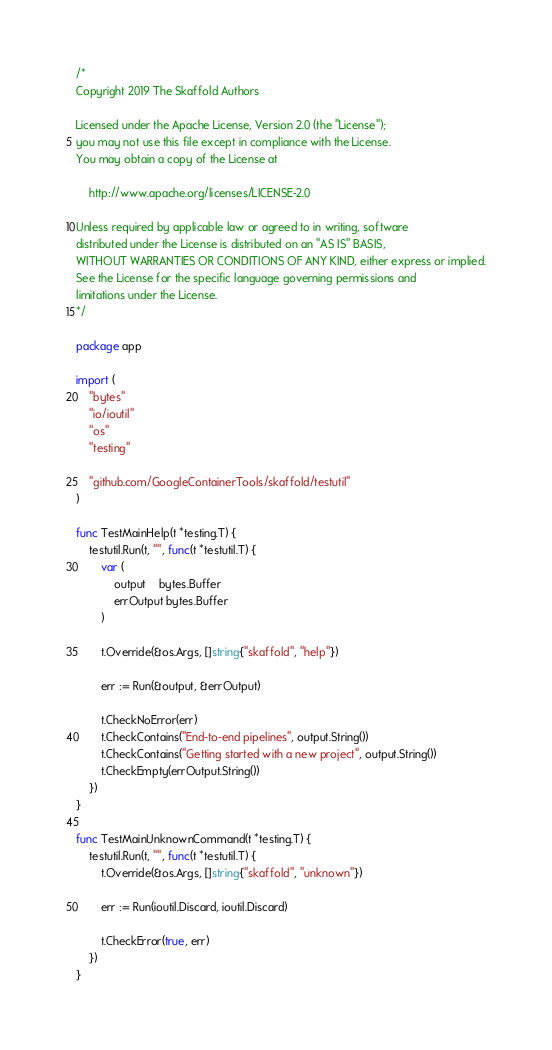Convert code to text. <code><loc_0><loc_0><loc_500><loc_500><_Go_>/*
Copyright 2019 The Skaffold Authors

Licensed under the Apache License, Version 2.0 (the "License");
you may not use this file except in compliance with the License.
You may obtain a copy of the License at

    http://www.apache.org/licenses/LICENSE-2.0

Unless required by applicable law or agreed to in writing, software
distributed under the License is distributed on an "AS IS" BASIS,
WITHOUT WARRANTIES OR CONDITIONS OF ANY KIND, either express or implied.
See the License for the specific language governing permissions and
limitations under the License.
*/

package app

import (
	"bytes"
	"io/ioutil"
	"os"
	"testing"

	"github.com/GoogleContainerTools/skaffold/testutil"
)

func TestMainHelp(t *testing.T) {
	testutil.Run(t, "", func(t *testutil.T) {
		var (
			output    bytes.Buffer
			errOutput bytes.Buffer
		)

		t.Override(&os.Args, []string{"skaffold", "help"})

		err := Run(&output, &errOutput)

		t.CheckNoError(err)
		t.CheckContains("End-to-end pipelines", output.String())
		t.CheckContains("Getting started with a new project", output.String())
		t.CheckEmpty(errOutput.String())
	})
}

func TestMainUnknownCommand(t *testing.T) {
	testutil.Run(t, "", func(t *testutil.T) {
		t.Override(&os.Args, []string{"skaffold", "unknown"})

		err := Run(ioutil.Discard, ioutil.Discard)

		t.CheckError(true, err)
	})
}
</code> 